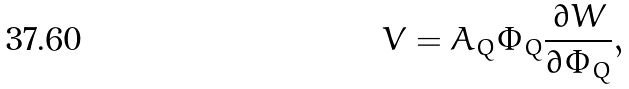Convert formula to latex. <formula><loc_0><loc_0><loc_500><loc_500>V = A _ { Q } \Phi _ { Q } \frac { \partial W } { \partial \Phi _ { Q } } ,</formula> 